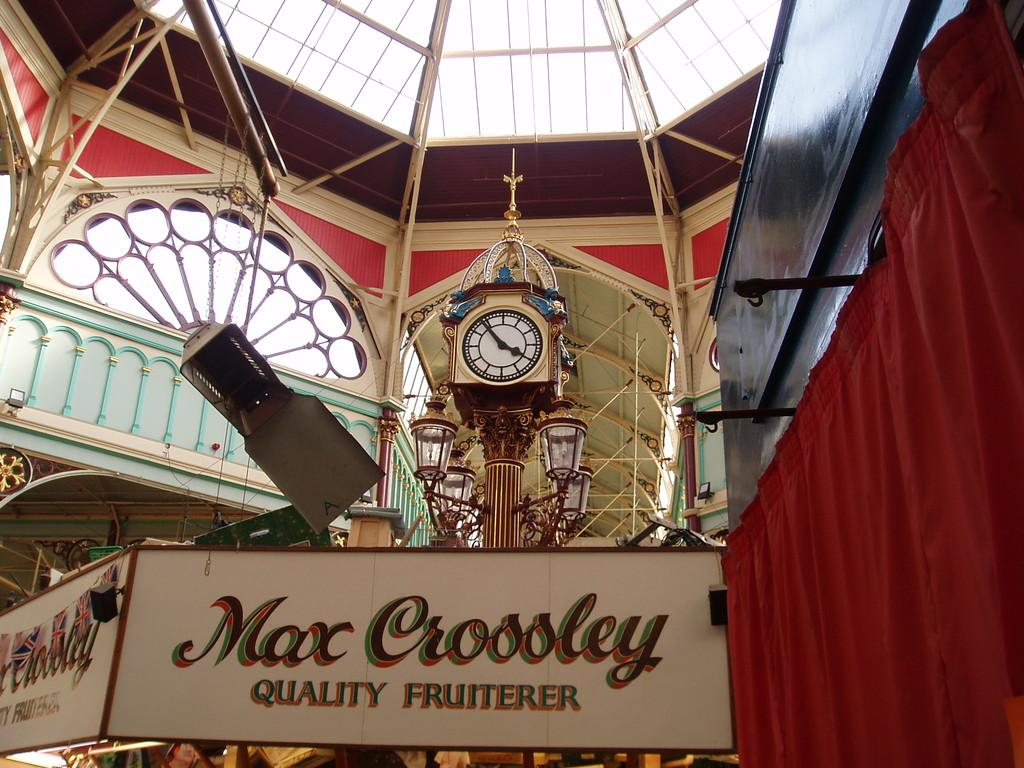<image>
Give a short and clear explanation of the subsequent image. a building with a clock in the center store is called max crossley 